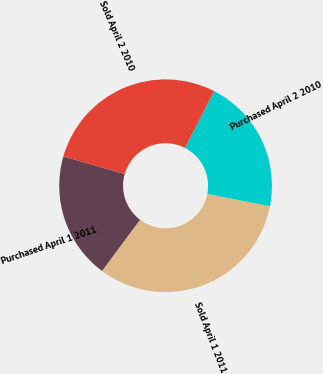Convert chart to OTSL. <chart><loc_0><loc_0><loc_500><loc_500><pie_chart><fcel>Purchased April 1 2011<fcel>Sold April 1 2011<fcel>Purchased April 2 2010<fcel>Sold April 2 2010<nl><fcel>19.27%<fcel>32.09%<fcel>20.55%<fcel>28.09%<nl></chart> 